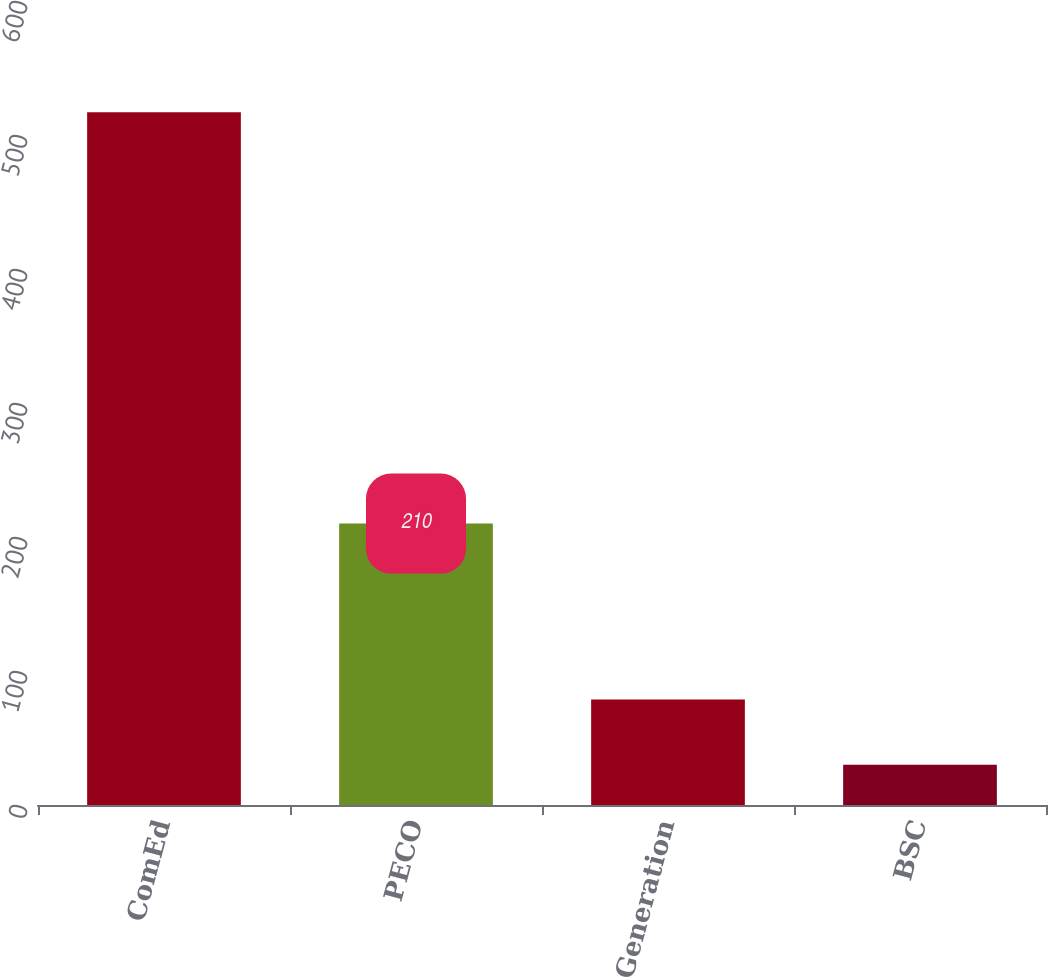<chart> <loc_0><loc_0><loc_500><loc_500><bar_chart><fcel>ComEd<fcel>PECO<fcel>Generation<fcel>BSC<nl><fcel>517<fcel>210<fcel>78.7<fcel>30<nl></chart> 